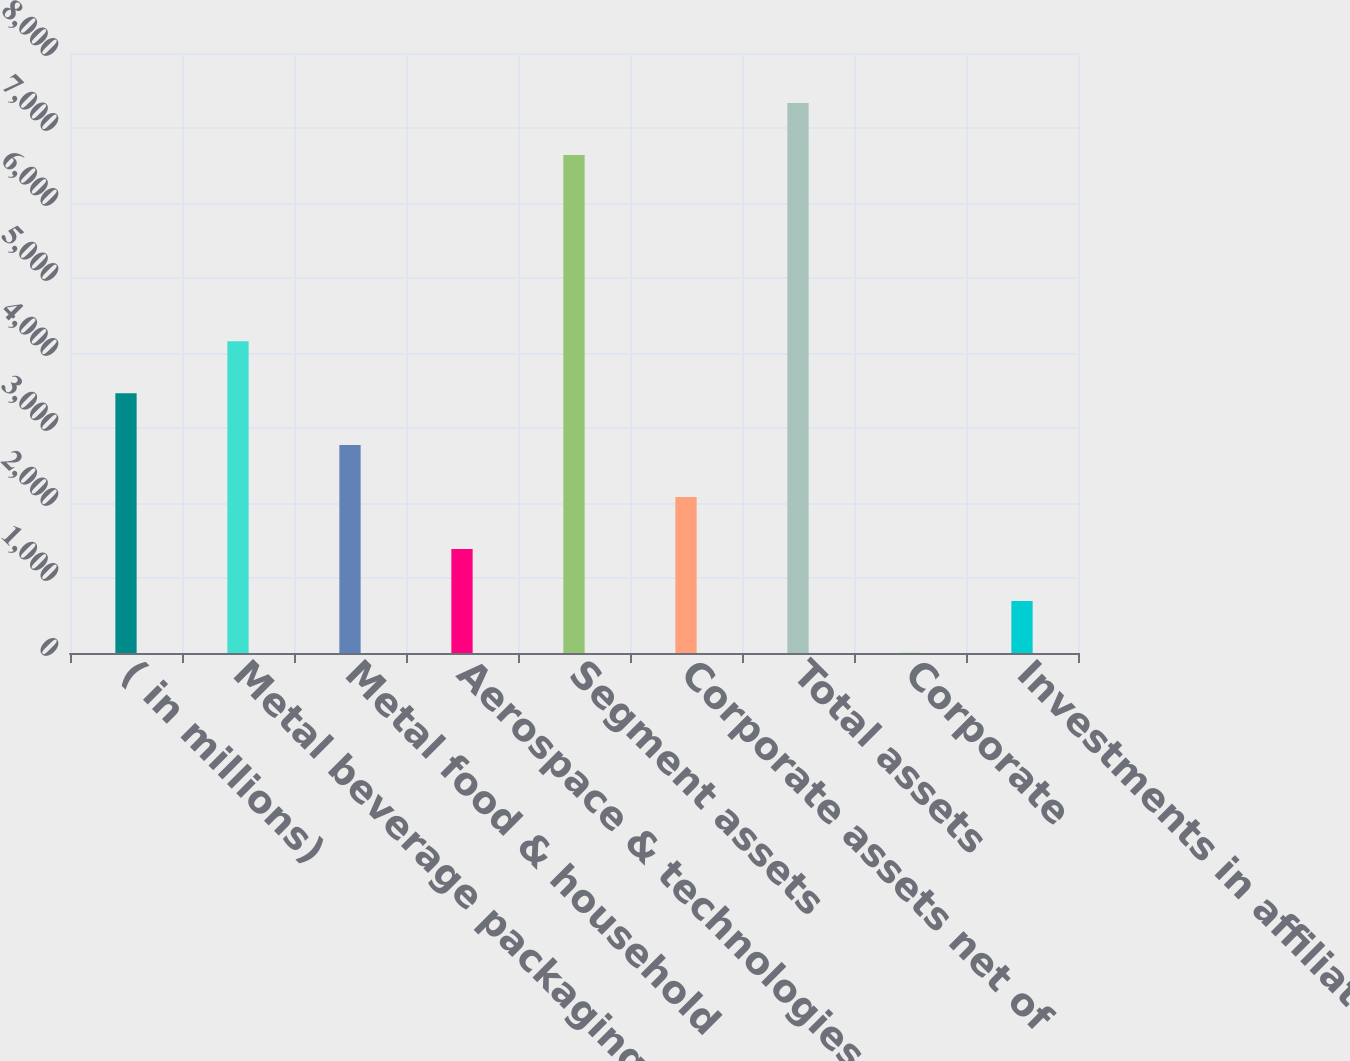Convert chart to OTSL. <chart><loc_0><loc_0><loc_500><loc_500><bar_chart><fcel>( in millions)<fcel>Metal beverage packaging<fcel>Metal food & household<fcel>Aerospace & technologies<fcel>Segment assets<fcel>Corporate assets net of<fcel>Total assets<fcel>Corporate<fcel>Investments in affiliates<nl><fcel>3464.65<fcel>4157.26<fcel>2772.04<fcel>1386.82<fcel>6641.6<fcel>2079.43<fcel>7334.21<fcel>1.6<fcel>694.21<nl></chart> 